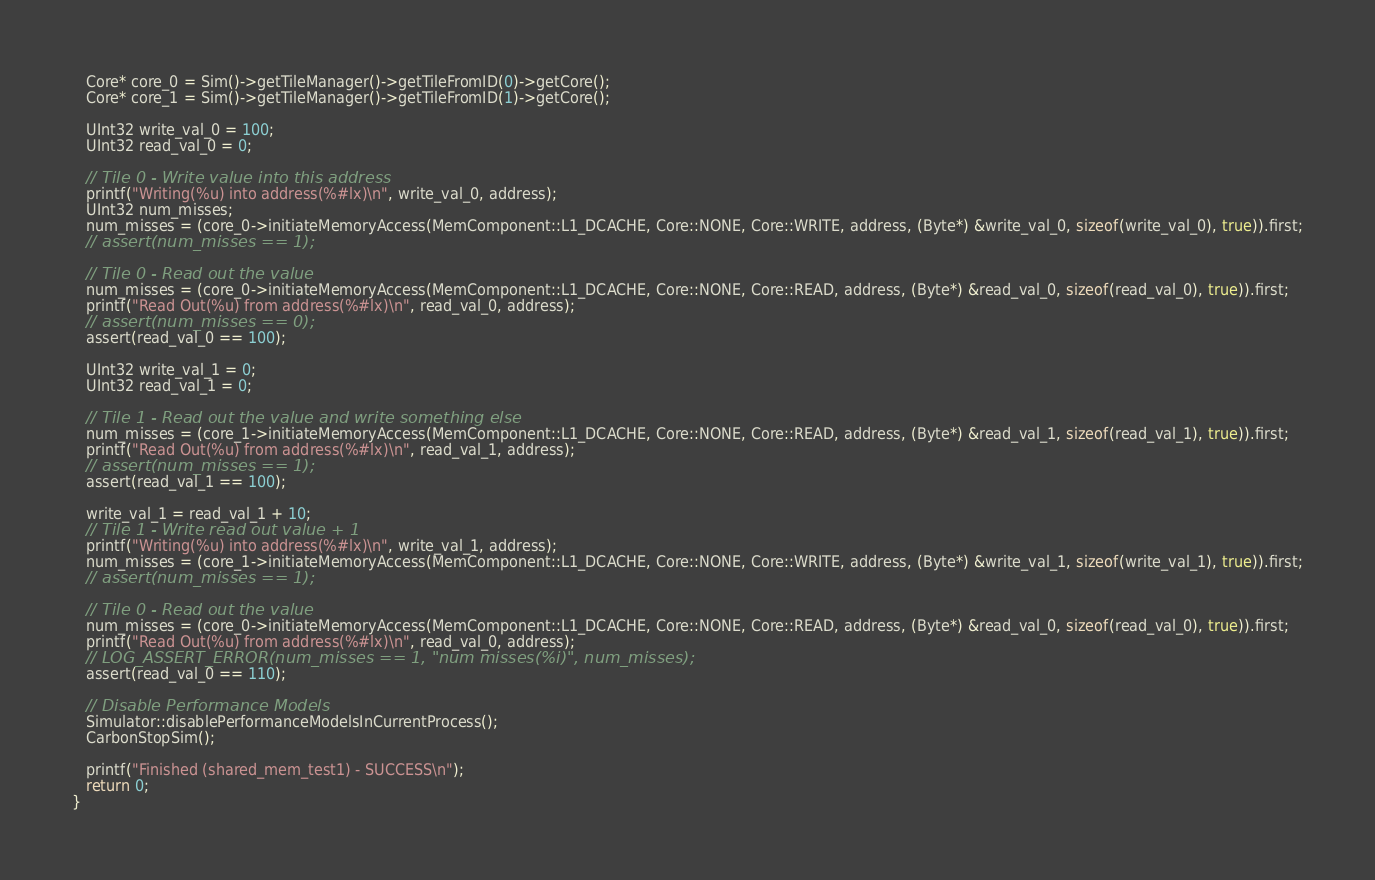<code> <loc_0><loc_0><loc_500><loc_500><_C++_>   Core* core_0 = Sim()->getTileManager()->getTileFromID(0)->getCore();
   Core* core_1 = Sim()->getTileManager()->getTileFromID(1)->getCore();

   UInt32 write_val_0 = 100;
   UInt32 read_val_0 = 0;

   // Tile 0 - Write value into this address
   printf("Writing(%u) into address(%#lx)\n", write_val_0, address);
   UInt32 num_misses;
   num_misses = (core_0->initiateMemoryAccess(MemComponent::L1_DCACHE, Core::NONE, Core::WRITE, address, (Byte*) &write_val_0, sizeof(write_val_0), true)).first;
   // assert(num_misses == 1);

   // Tile 0 - Read out the value
   num_misses = (core_0->initiateMemoryAccess(MemComponent::L1_DCACHE, Core::NONE, Core::READ, address, (Byte*) &read_val_0, sizeof(read_val_0), true)).first;
   printf("Read Out(%u) from address(%#lx)\n", read_val_0, address);
   // assert(num_misses == 0);
   assert(read_val_0 == 100);

   UInt32 write_val_1 = 0;
   UInt32 read_val_1 = 0;

   // Tile 1 - Read out the value and write something else
   num_misses = (core_1->initiateMemoryAccess(MemComponent::L1_DCACHE, Core::NONE, Core::READ, address, (Byte*) &read_val_1, sizeof(read_val_1), true)).first;
   printf("Read Out(%u) from address(%#lx)\n", read_val_1, address);
   // assert(num_misses == 1);
   assert(read_val_1 == 100);

   write_val_1 = read_val_1 + 10;
   // Tile 1 - Write read out value + 1
   printf("Writing(%u) into address(%#lx)\n", write_val_1, address);
   num_misses = (core_1->initiateMemoryAccess(MemComponent::L1_DCACHE, Core::NONE, Core::WRITE, address, (Byte*) &write_val_1, sizeof(write_val_1), true)).first;
   // assert(num_misses == 1);
   
   // Tile 0 - Read out the value
   num_misses = (core_0->initiateMemoryAccess(MemComponent::L1_DCACHE, Core::NONE, Core::READ, address, (Byte*) &read_val_0, sizeof(read_val_0), true)).first;
   printf("Read Out(%u) from address(%#lx)\n", read_val_0, address);
   // LOG_ASSERT_ERROR(num_misses == 1, "num misses(%i)", num_misses);
   assert(read_val_0 == 110);

   // Disable Performance Models
   Simulator::disablePerformanceModelsInCurrentProcess();
   CarbonStopSim();
   
   printf("Finished (shared_mem_test1) - SUCCESS\n");
   return 0;
}
</code> 